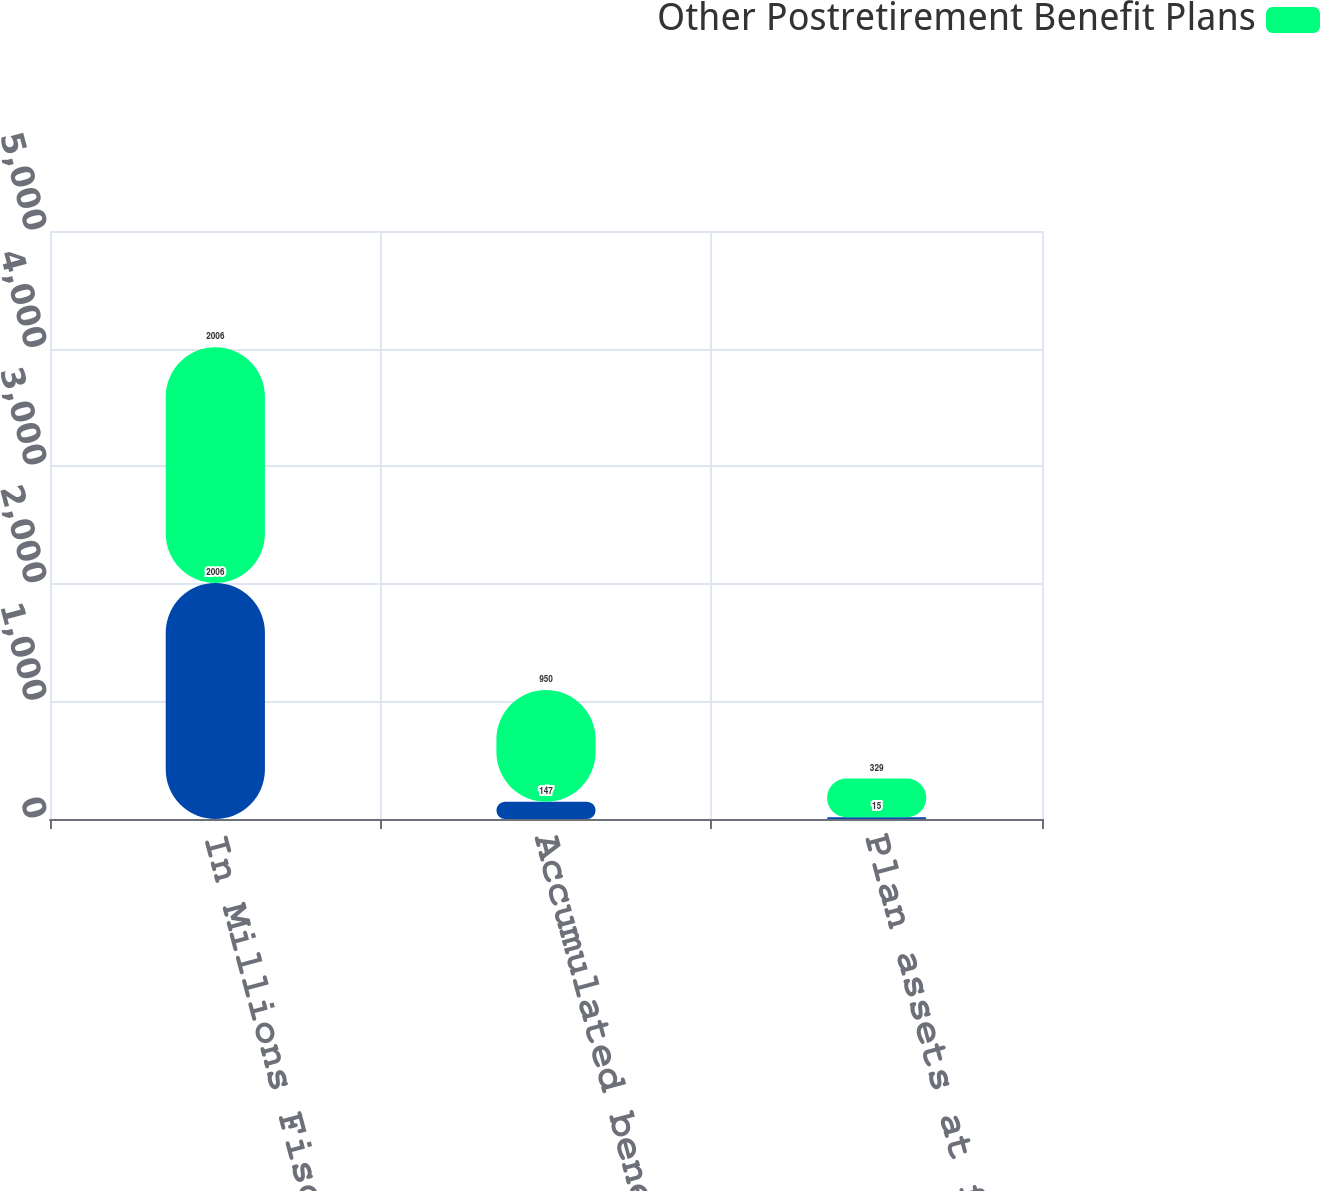<chart> <loc_0><loc_0><loc_500><loc_500><stacked_bar_chart><ecel><fcel>In Millions Fiscal Year End<fcel>Accumulated benefit obligation<fcel>Plan assets at fair value<nl><fcel>nan<fcel>2006<fcel>147<fcel>15<nl><fcel>Other Postretirement Benefit Plans<fcel>2006<fcel>950<fcel>329<nl></chart> 